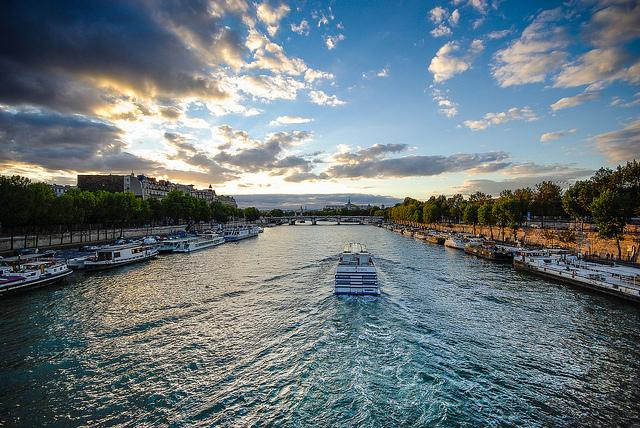What is creating the larger waves?

Choices:
A) wind
B) kids
C) falling objects
D) boat boat 